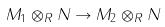Convert formula to latex. <formula><loc_0><loc_0><loc_500><loc_500>M _ { 1 } \otimes _ { R } N \to M _ { 2 } \otimes _ { R } N</formula> 